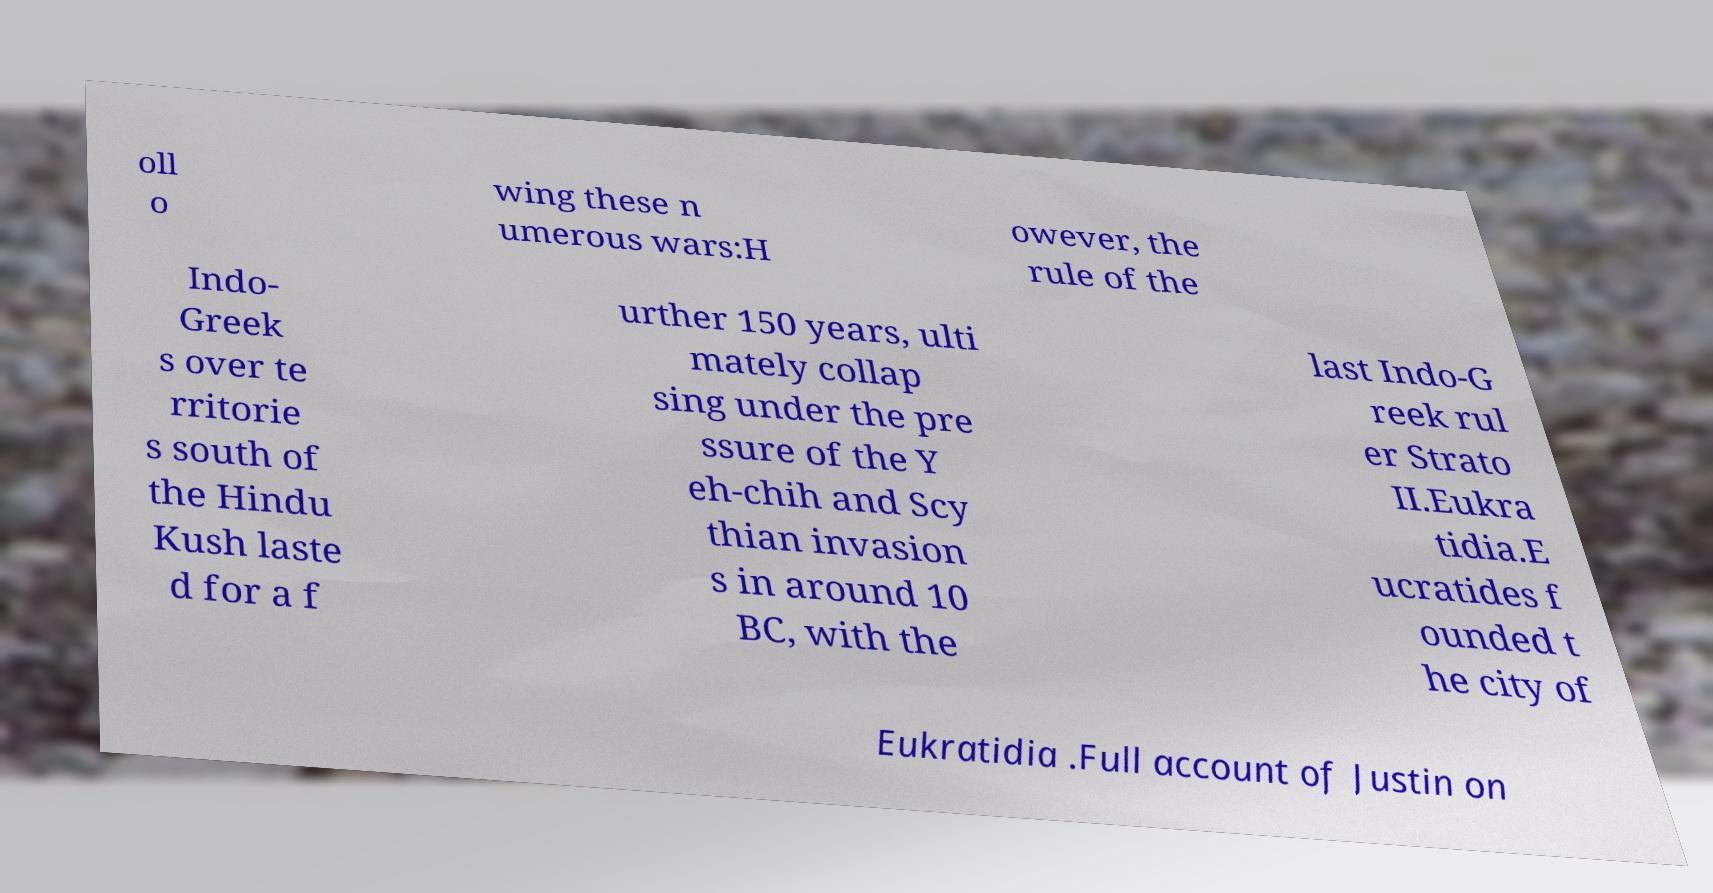Could you extract and type out the text from this image? oll o wing these n umerous wars:H owever, the rule of the Indo- Greek s over te rritorie s south of the Hindu Kush laste d for a f urther 150 years, ulti mately collap sing under the pre ssure of the Y eh-chih and Scy thian invasion s in around 10 BC, with the last Indo-G reek rul er Strato II.Eukra tidia.E ucratides f ounded t he city of Eukratidia .Full account of Justin on 